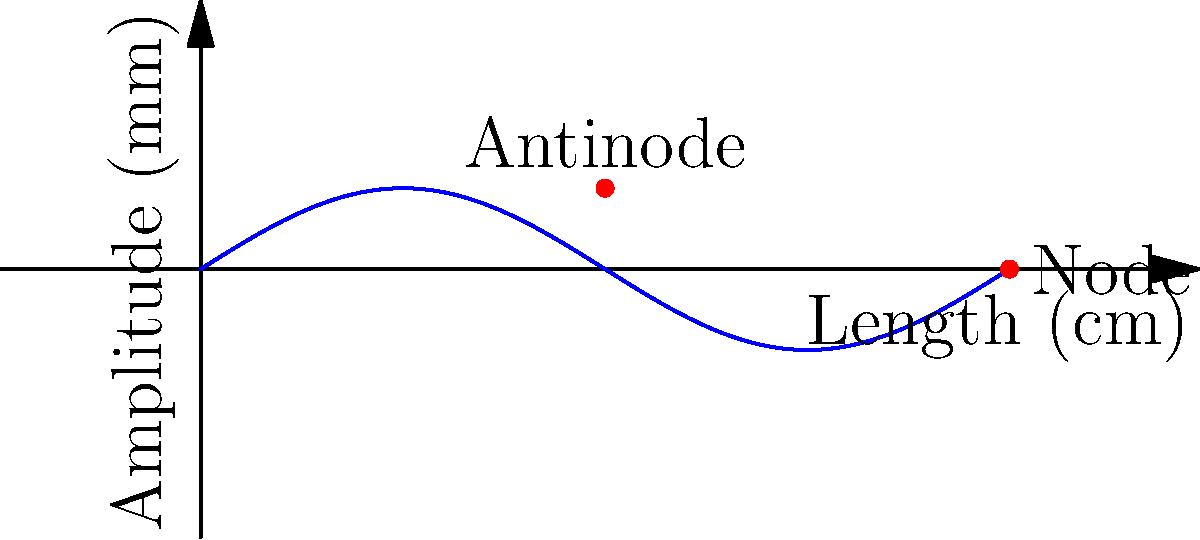In this diagram of a violin string's first harmonic, what is the wavelength in centimeters if the string length is 20 cm? To determine the wavelength of the first harmonic, let's follow these steps:

1. Observe the diagram: It shows one complete wave cycle within the string length.

2. Recall the relationship between wavelength and string length for the first harmonic:
   The wavelength ($\lambda$) of the first harmonic is twice the length of the string.

3. Given information:
   String length = 20 cm

4. Calculate the wavelength:
   $\lambda = 2 \times \text{String length}$
   $\lambda = 2 \times 20 \text{ cm}$
   $\lambda = 40 \text{ cm}$

5. Verify visually:
   The diagram shows one complete wave cycle (from node to node) spanning the entire string length, which confirms our calculation.
Answer: 40 cm 